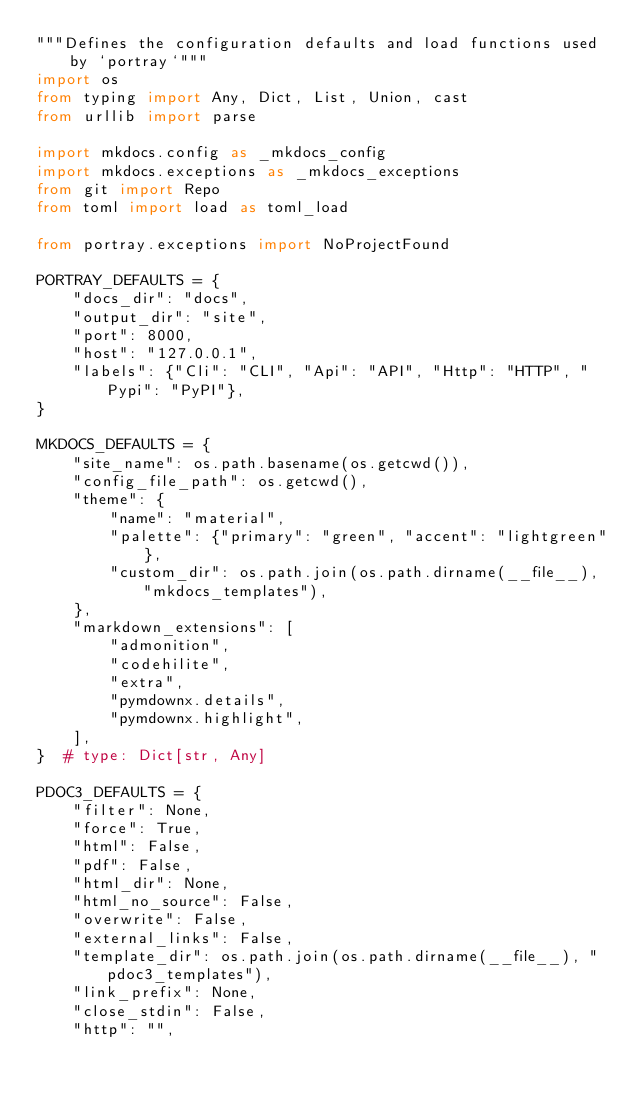Convert code to text. <code><loc_0><loc_0><loc_500><loc_500><_Python_>"""Defines the configuration defaults and load functions used by `portray`"""
import os
from typing import Any, Dict, List, Union, cast
from urllib import parse

import mkdocs.config as _mkdocs_config
import mkdocs.exceptions as _mkdocs_exceptions
from git import Repo
from toml import load as toml_load

from portray.exceptions import NoProjectFound

PORTRAY_DEFAULTS = {
    "docs_dir": "docs",
    "output_dir": "site",
    "port": 8000,
    "host": "127.0.0.1",
    "labels": {"Cli": "CLI", "Api": "API", "Http": "HTTP", "Pypi": "PyPI"},
}

MKDOCS_DEFAULTS = {
    "site_name": os.path.basename(os.getcwd()),
    "config_file_path": os.getcwd(),
    "theme": {
        "name": "material",
        "palette": {"primary": "green", "accent": "lightgreen"},
        "custom_dir": os.path.join(os.path.dirname(__file__), "mkdocs_templates"),
    },
    "markdown_extensions": [
        "admonition",
        "codehilite",
        "extra",
        "pymdownx.details",
        "pymdownx.highlight",
    ],
}  # type: Dict[str, Any]

PDOC3_DEFAULTS = {
    "filter": None,
    "force": True,
    "html": False,
    "pdf": False,
    "html_dir": None,
    "html_no_source": False,
    "overwrite": False,
    "external_links": False,
    "template_dir": os.path.join(os.path.dirname(__file__), "pdoc3_templates"),
    "link_prefix": None,
    "close_stdin": False,
    "http": "",</code> 